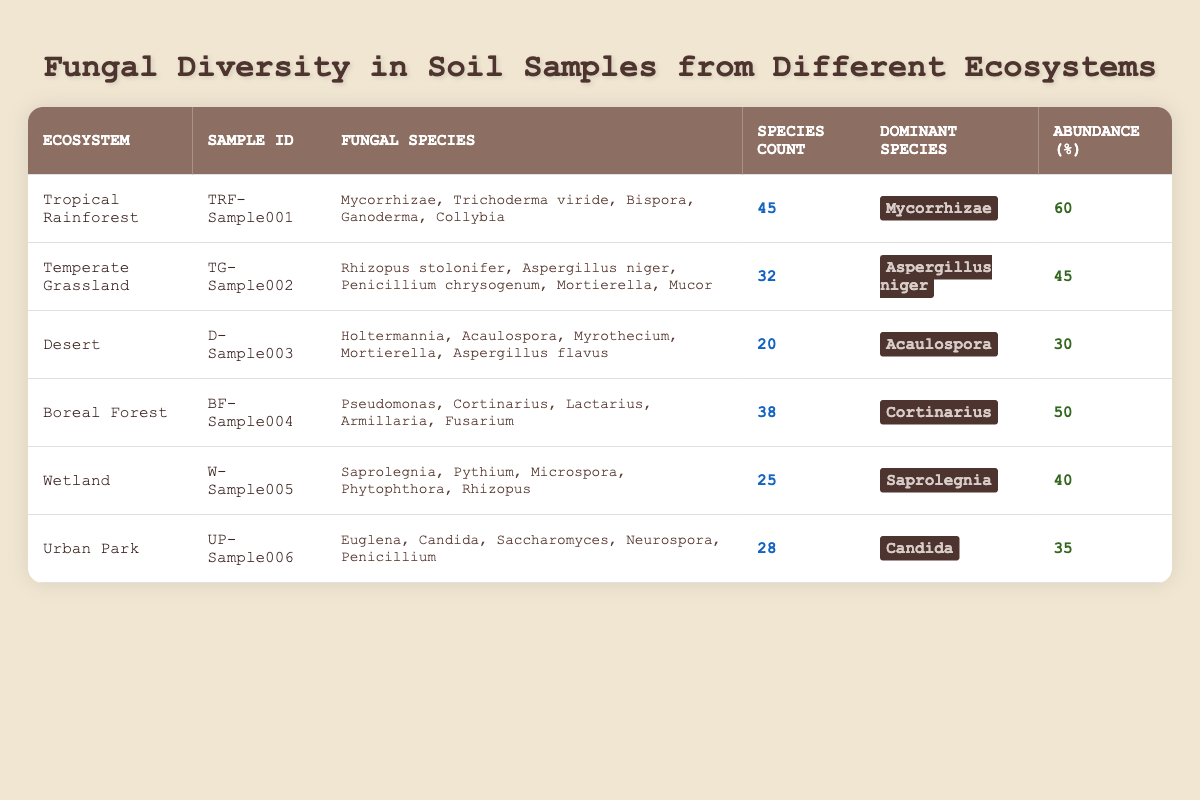What is the dominant fungal species in the Tropical Rainforest ecosystem? From the table, under the Tropical Rainforest row, the dominant species listed is **Mycorrhizae**.
Answer: Mycorrhizae How many fungal species are found in the Temperate Grassland ecosystem? The Species Count for the Temperate Grassland ecosystem, as seen in the table, is **32**.
Answer: 32 Is Acaulospora the dominant species in the Desert ecosystem? Yes, the table indicates that Acaulospora is the dominant species listed for the Desert ecosystem.
Answer: Yes Which ecosystem has the highest fungal abundance, and what is that value? By comparing values in the Abundance column, the Tropical Rainforest shows an abundance value of **60**, which is the highest among the listed ecosystems.
Answer: 60 What is the total number of fungal species counted across all ecosystems? Adding up the Species Count values: 45 (Tropical Rainforest) + 32 (Temperate Grassland) + 20 (Desert) + 38 (Boreal Forest) + 25 (Wetland) + 28 (Urban Park) equals 188.
Answer: 188 Which ecosystem has the lowest species count, and what is the value? Upon checking the Species Count, the Desert ecosystem has the lowest value of **20**.
Answer: 20 Is it true that all ecosystems have a species count of at least 25? No, looking at the Desert ecosystem, it shows a species count of **20**, which is below 25.
Answer: No Calculate the average abundance of fungi across all ecosystems. The total abundance is: 60 (Tropical Rainforest) + 45 (Temperate Grassland) + 30 (Desert) + 50 (Boreal Forest) + 40 (Wetland) + 35 (Urban Park) = 260. There are 6 ecosystems, so the average abundance is 260/6 = **43.33**.
Answer: 43.33 Which ecosystem has the second highest species count? Ranking the Species Count values from highest to lowest gives the following order: Tropical Rainforest (45), Boreal Forest (38), Temperate Grassland (32), Urban Park (28), Wetland (25), Desert (20). Thus, Boreal Forest with **38** is in second place.
Answer: 38 What is the relationship between species count and abundance in the Boreal Forest? For the Boreal Forest, the Species Count is **38** and the Abundance is **50**. This indicates a positive relationship as the abundance is substantial given the number of species present.
Answer: Positive relationship 